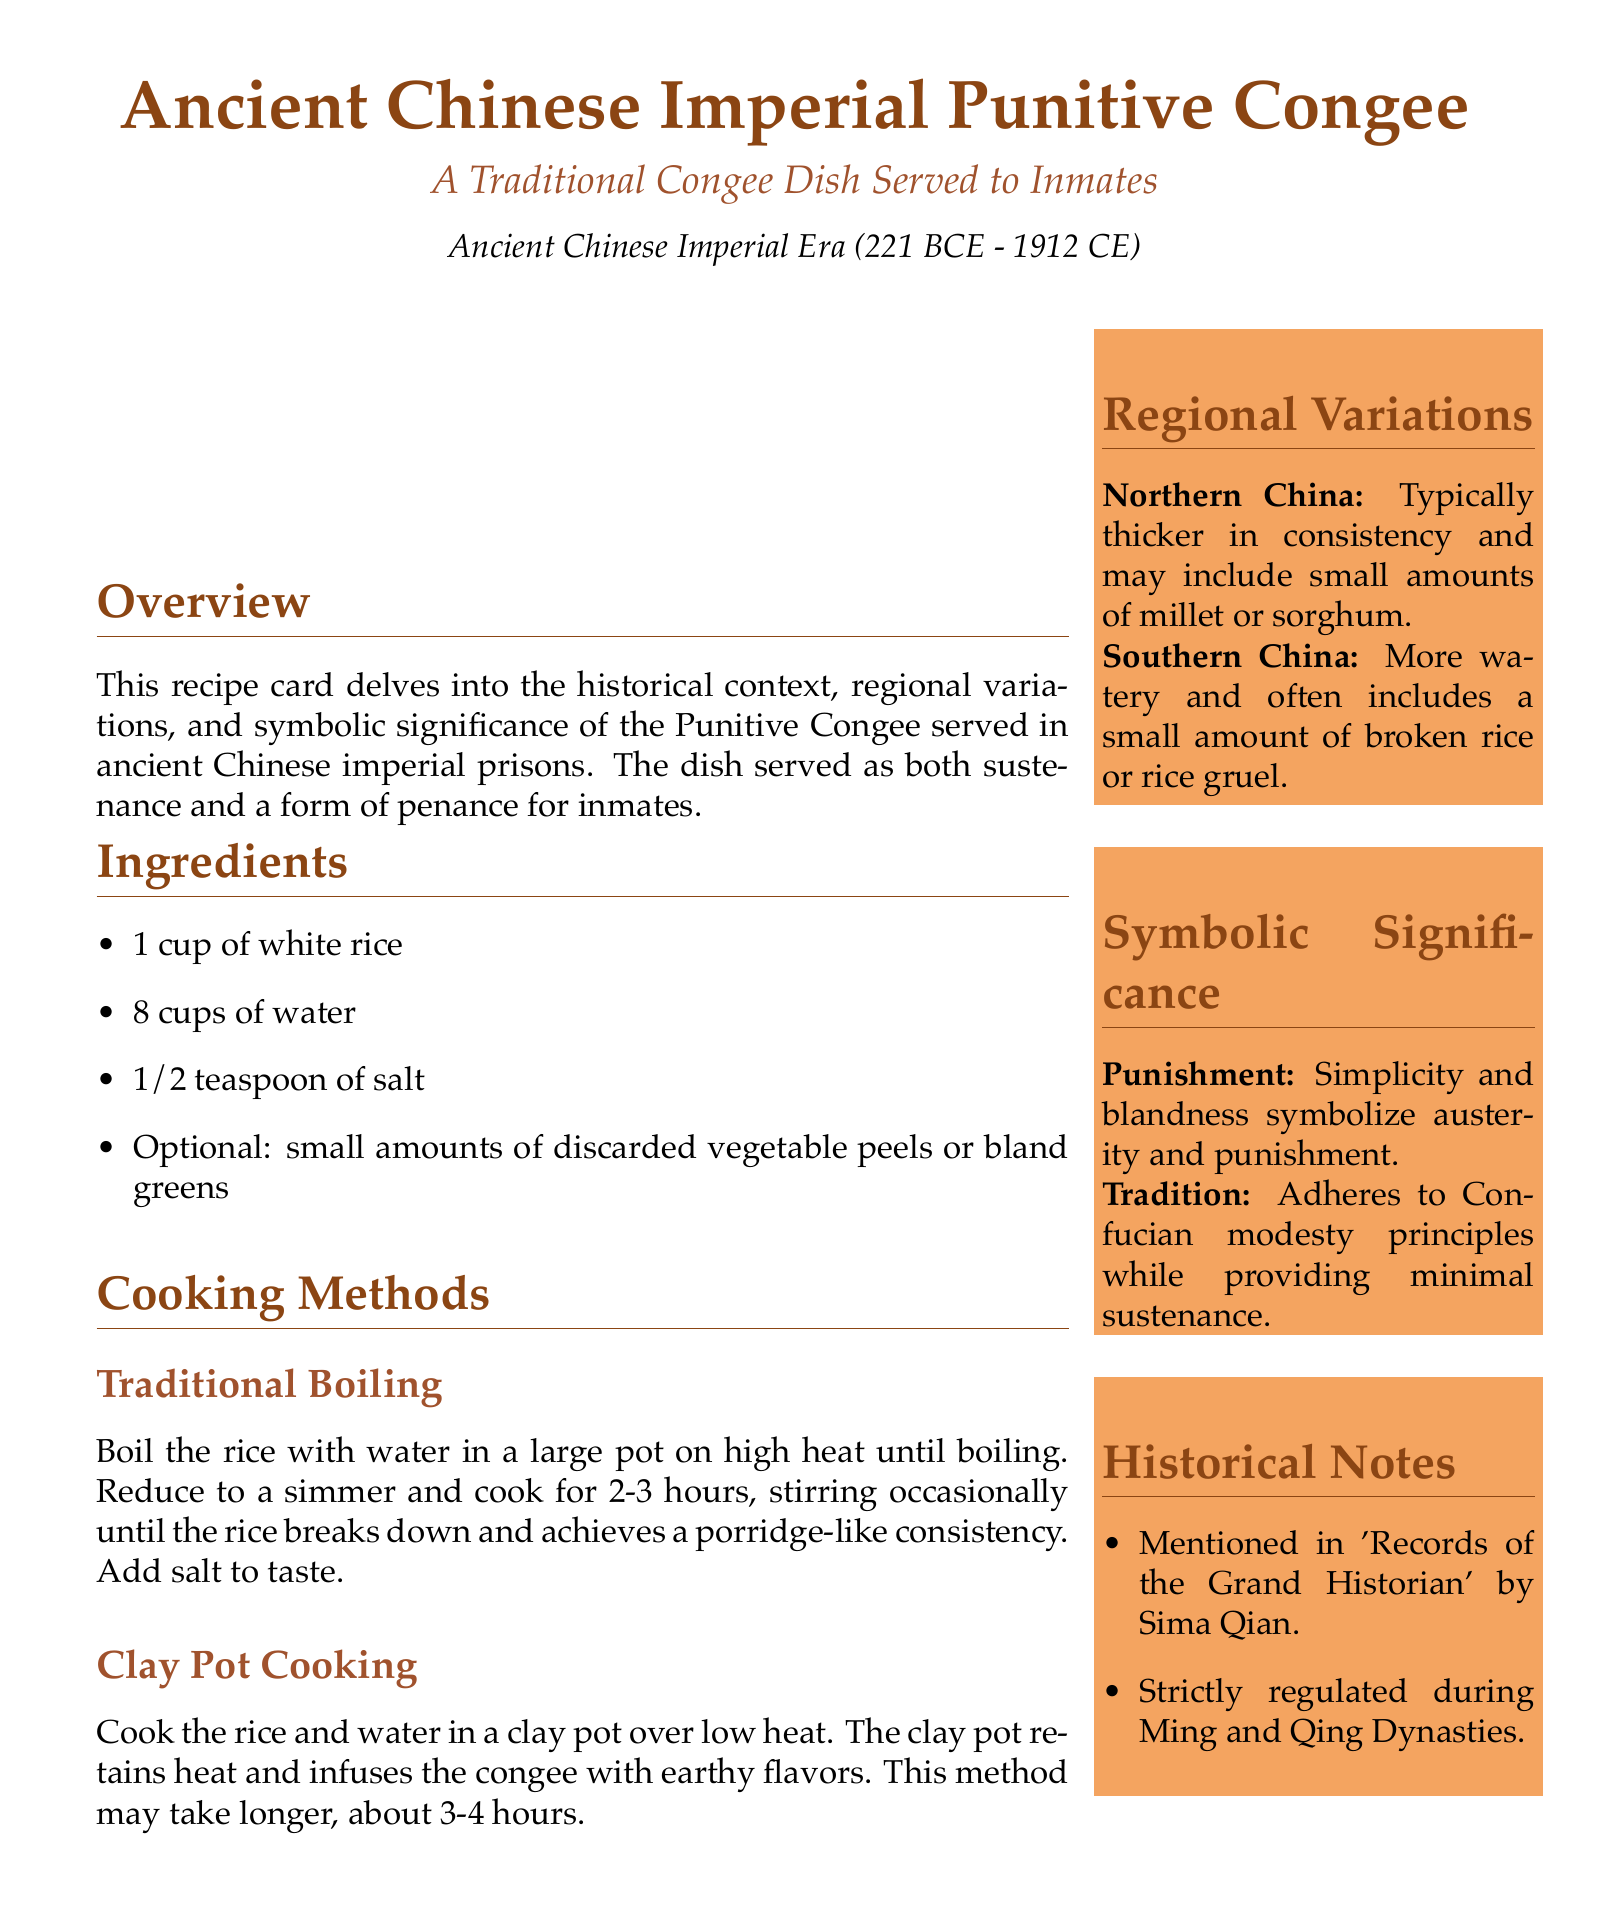what is the main ingredient of the congee? The main ingredient of the congee listed in the document is white rice.
Answer: white rice how long should the traditional boiling method take? The traditional boiling method requires cooking for 2-3 hours according to the document.
Answer: 2-3 hours what is an optional addition to the congee? The document mentions small amounts of discarded vegetable peels or bland greens as an optional addition.
Answer: discarded vegetable peels or bland greens what does the congee symbolize in terms of punishment? The congee's simplicity and blandness symbolize austerity and punishment as stated in the document.
Answer: austerity and punishment what cooking method may take longer? The document states that the clay pot cooking method may take longer than traditional boiling.
Answer: clay pot cooking which region typically has thicker congee? The document indicates that Northern China typically has thicker congee.
Answer: Northern China in which historical document is the congee mentioned? The congee is mentioned in 'Records of the Grand Historian' by Sima Qian according to the historical notes.
Answer: Records of the Grand Historian what principle does the congee adhere to? The congee adheres to Confucian modesty principles as highlighted in the document.
Answer: Confucian modesty principles 